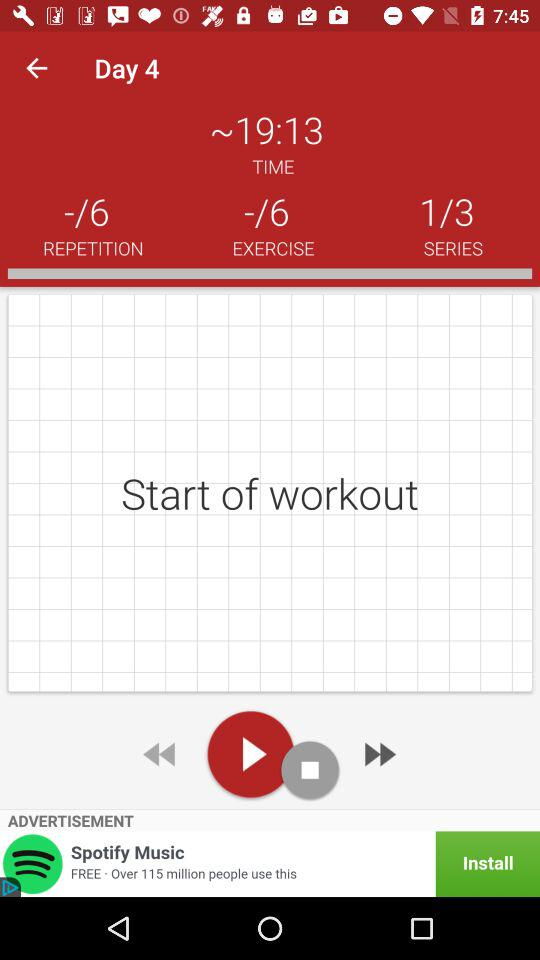What day of the workout are we on? You are on day 4. 